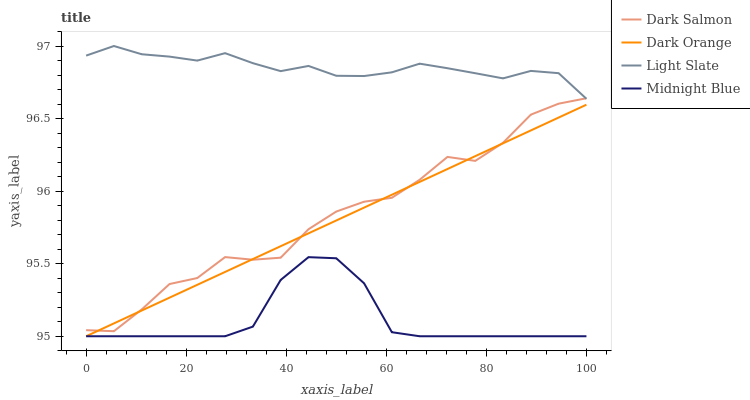Does Midnight Blue have the minimum area under the curve?
Answer yes or no. Yes. Does Light Slate have the maximum area under the curve?
Answer yes or no. Yes. Does Dark Orange have the minimum area under the curve?
Answer yes or no. No. Does Dark Orange have the maximum area under the curve?
Answer yes or no. No. Is Dark Orange the smoothest?
Answer yes or no. Yes. Is Dark Salmon the roughest?
Answer yes or no. Yes. Is Dark Salmon the smoothest?
Answer yes or no. No. Is Dark Orange the roughest?
Answer yes or no. No. Does Dark Salmon have the lowest value?
Answer yes or no. No. Does Light Slate have the highest value?
Answer yes or no. Yes. Does Dark Orange have the highest value?
Answer yes or no. No. Is Midnight Blue less than Dark Salmon?
Answer yes or no. Yes. Is Light Slate greater than Dark Orange?
Answer yes or no. Yes. Does Dark Salmon intersect Light Slate?
Answer yes or no. Yes. Is Dark Salmon less than Light Slate?
Answer yes or no. No. Is Dark Salmon greater than Light Slate?
Answer yes or no. No. Does Midnight Blue intersect Dark Salmon?
Answer yes or no. No. 